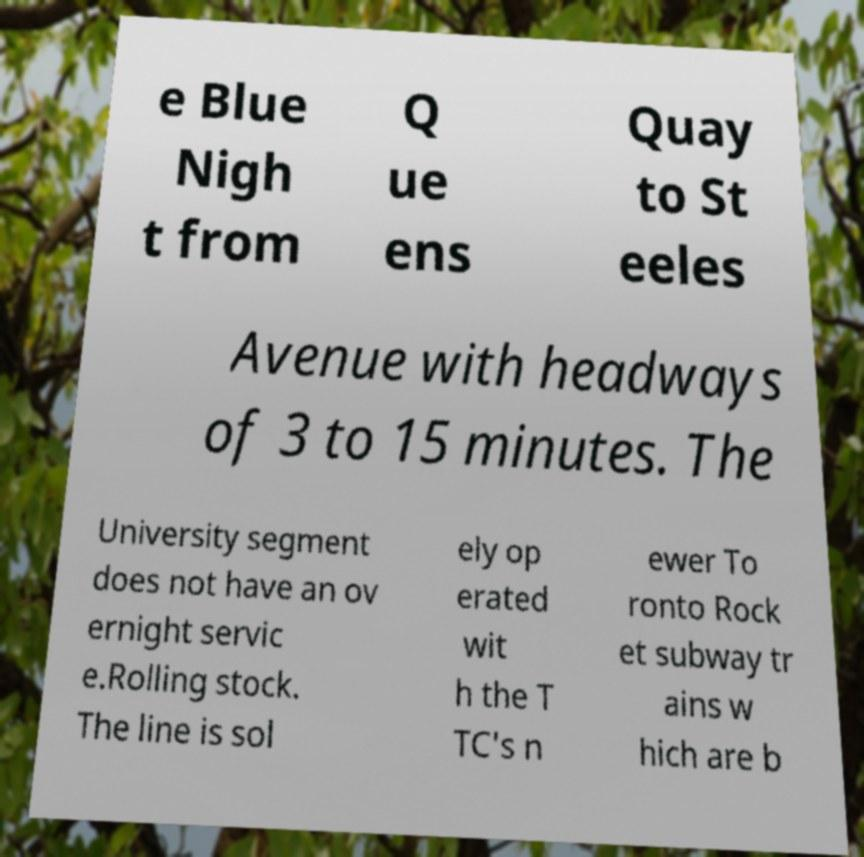Could you extract and type out the text from this image? e Blue Nigh t from Q ue ens Quay to St eeles Avenue with headways of 3 to 15 minutes. The University segment does not have an ov ernight servic e.Rolling stock. The line is sol ely op erated wit h the T TC's n ewer To ronto Rock et subway tr ains w hich are b 